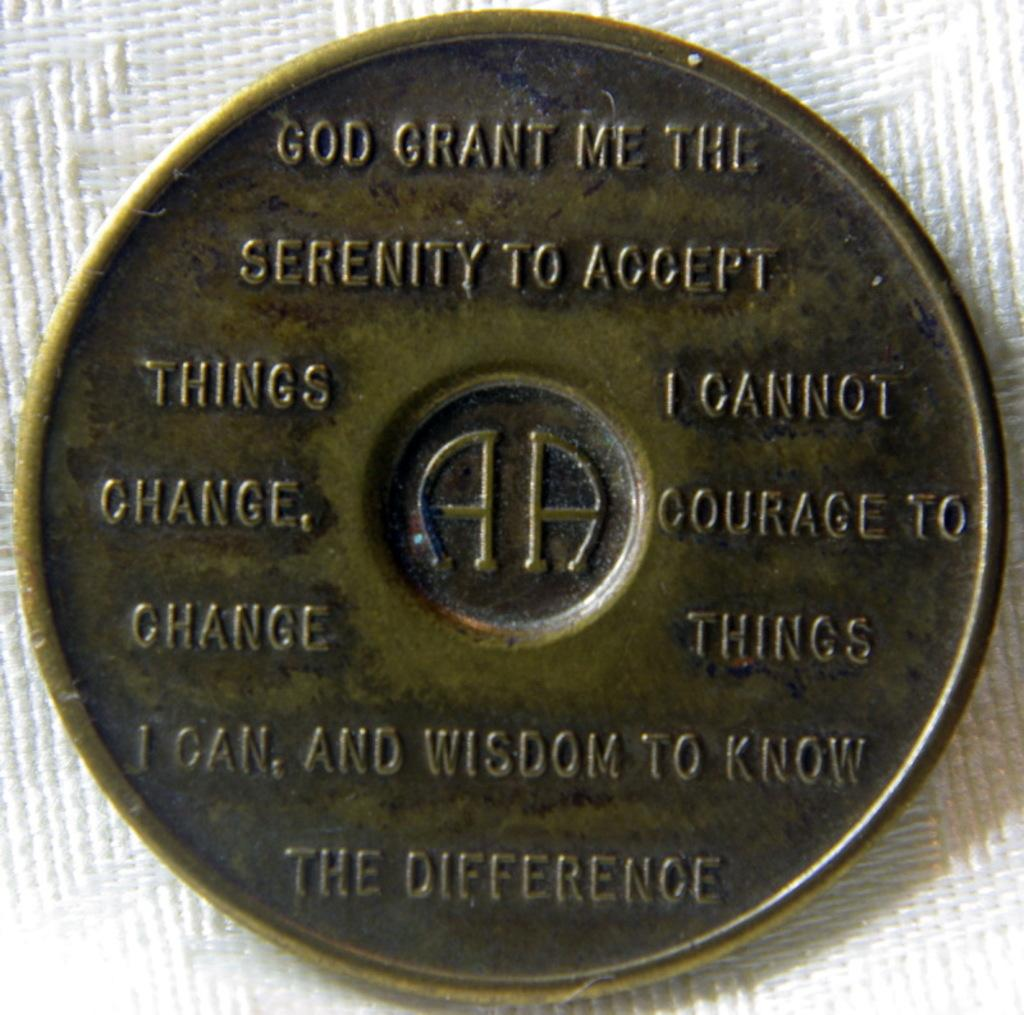<image>
Render a clear and concise summary of the photo. A gold coin token that has a prayer that says God grant me the. 